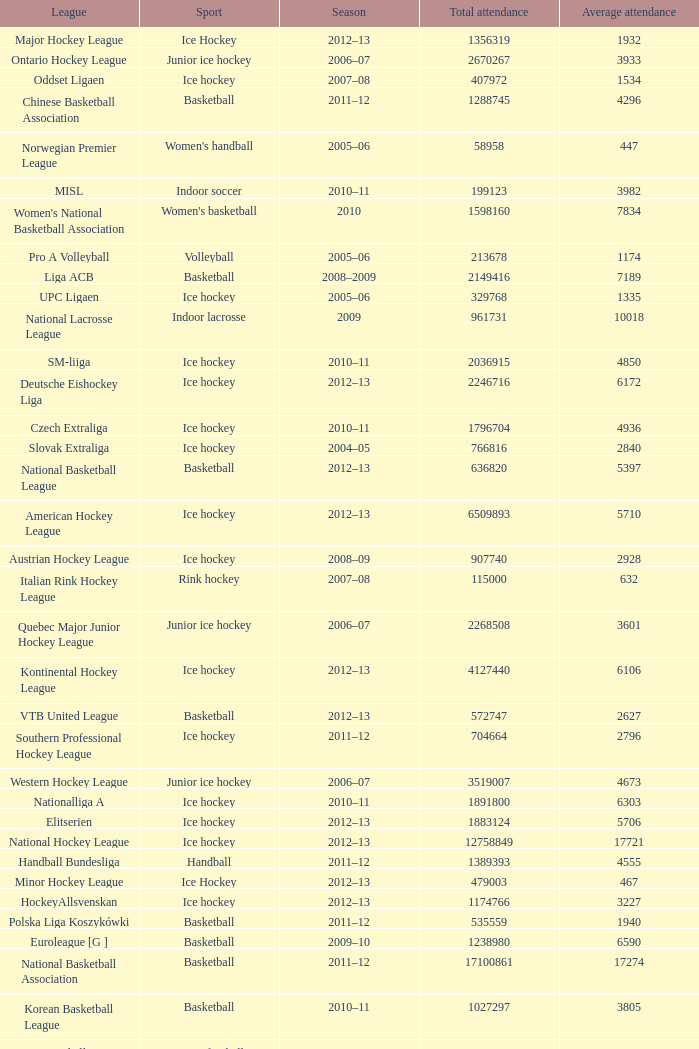What was the highest average attendance in the 2009 season? 10018.0. 